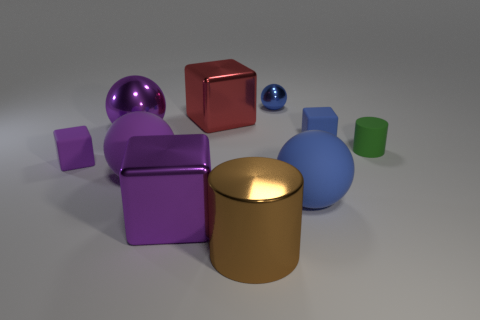Subtract all blue cubes. How many cubes are left? 3 Subtract 1 blocks. How many blocks are left? 3 Subtract all gray blocks. Subtract all purple balls. How many blocks are left? 4 Subtract all cylinders. How many objects are left? 8 Subtract all small purple objects. Subtract all brown cylinders. How many objects are left? 8 Add 1 matte cylinders. How many matte cylinders are left? 2 Add 5 tiny purple metallic balls. How many tiny purple metallic balls exist? 5 Subtract 1 brown cylinders. How many objects are left? 9 